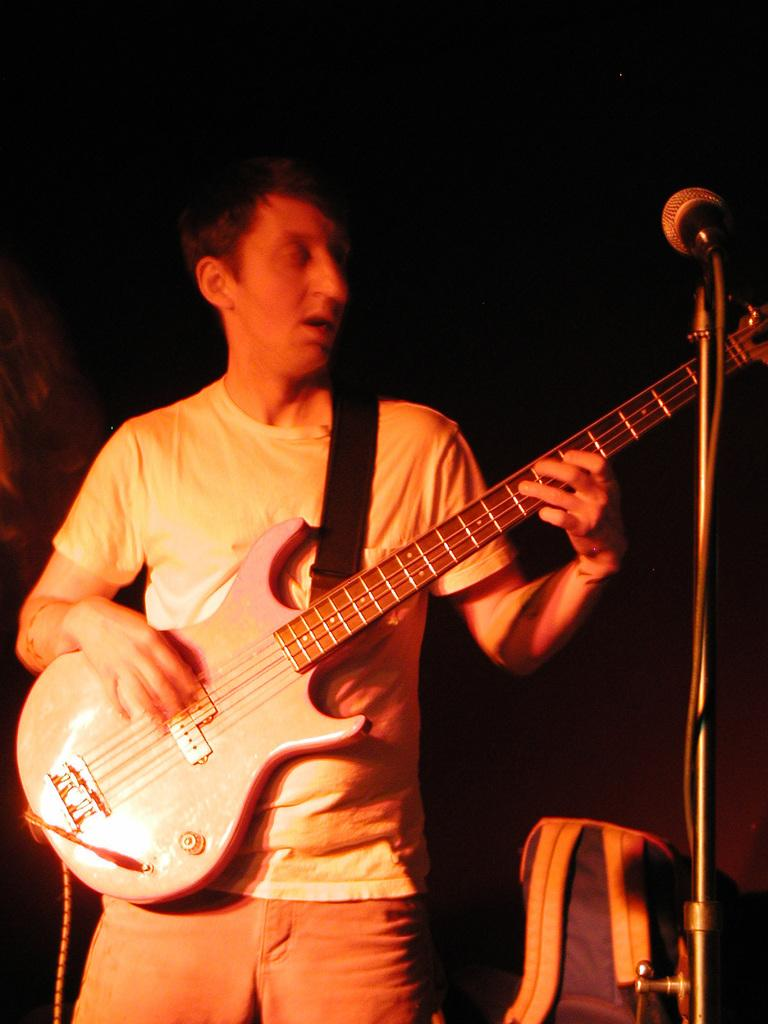What is the man in the image doing? The man is playing a guitar. What object is the man positioned in front of? The man is in front of a microphone. Can you describe anything visible in the background of the image? There is a backpack visible in the background of the image. What type of shop can be seen in the background of the image? There is no shop visible in the background of the image. What historical event is the man commemorating by playing the guitar? The image does not provide any information about a historical event or the man's intentions, so it cannot be determined from the image. 